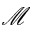<formula> <loc_0><loc_0><loc_500><loc_500>\mathcal { M }</formula> 